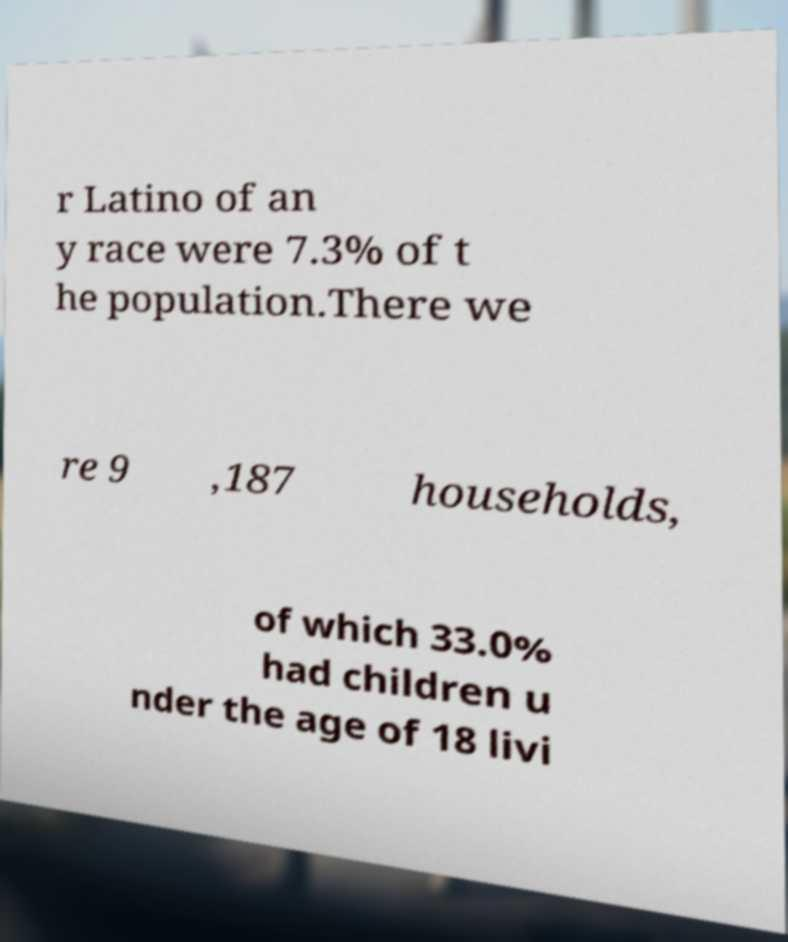For documentation purposes, I need the text within this image transcribed. Could you provide that? r Latino of an y race were 7.3% of t he population.There we re 9 ,187 households, of which 33.0% had children u nder the age of 18 livi 